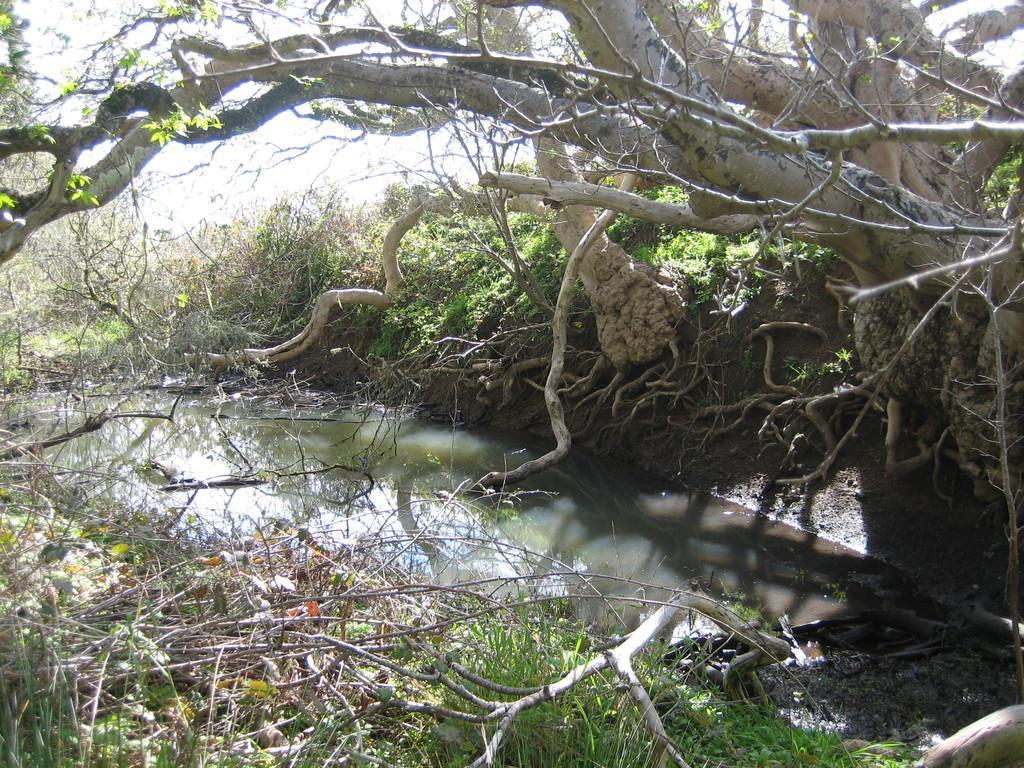How would you summarize this image in a sentence or two? There is a tree in the right top corner and there is water below it and there are few plants on either sides of it. 